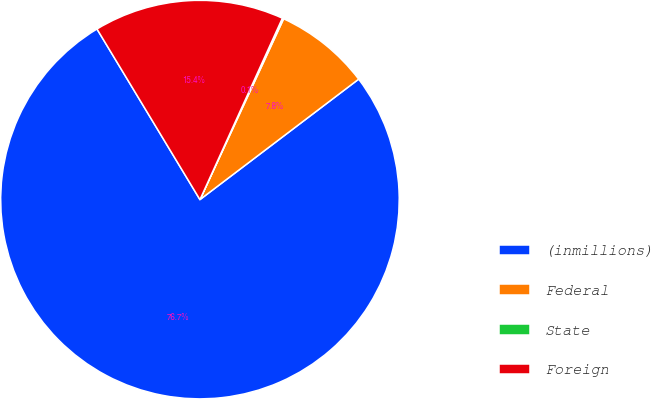<chart> <loc_0><loc_0><loc_500><loc_500><pie_chart><fcel>(inmillions)<fcel>Federal<fcel>State<fcel>Foreign<nl><fcel>76.69%<fcel>7.77%<fcel>0.11%<fcel>15.43%<nl></chart> 